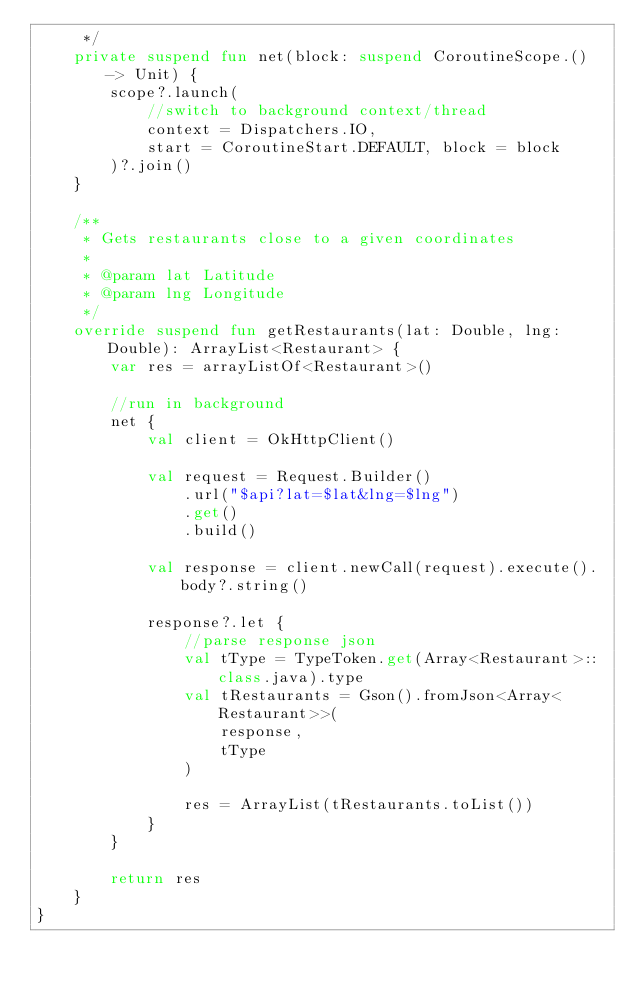<code> <loc_0><loc_0><loc_500><loc_500><_Kotlin_>     */
    private suspend fun net(block: suspend CoroutineScope.() -> Unit) {
        scope?.launch(
            //switch to background context/thread
            context = Dispatchers.IO,
            start = CoroutineStart.DEFAULT, block = block
        )?.join()
    }

    /**
     * Gets restaurants close to a given coordinates
     *
     * @param lat Latitude
     * @param lng Longitude
     */
    override suspend fun getRestaurants(lat: Double, lng: Double): ArrayList<Restaurant> {
        var res = arrayListOf<Restaurant>()

        //run in background
        net {
            val client = OkHttpClient()

            val request = Request.Builder()
                .url("$api?lat=$lat&lng=$lng")
                .get()
                .build()

            val response = client.newCall(request).execute().body?.string()

            response?.let {
                //parse response json
                val tType = TypeToken.get(Array<Restaurant>::class.java).type
                val tRestaurants = Gson().fromJson<Array<Restaurant>>(
                    response,
                    tType
                )

                res = ArrayList(tRestaurants.toList())
            }
        }

        return res
    }
}</code> 